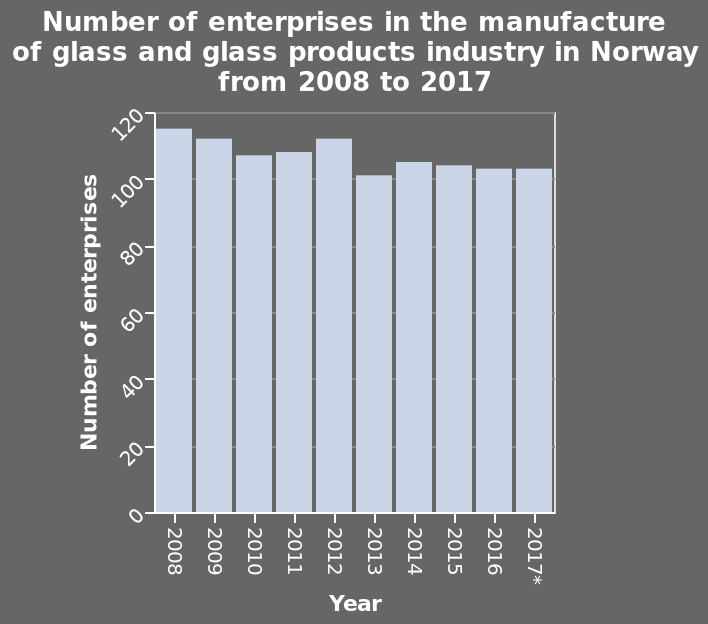<image>
 What is the title of the bar plot?  The title of the bar plot is "Number of enterprises in the manufacture of glass and glass products industry in Norway from 2008 to 2017." 